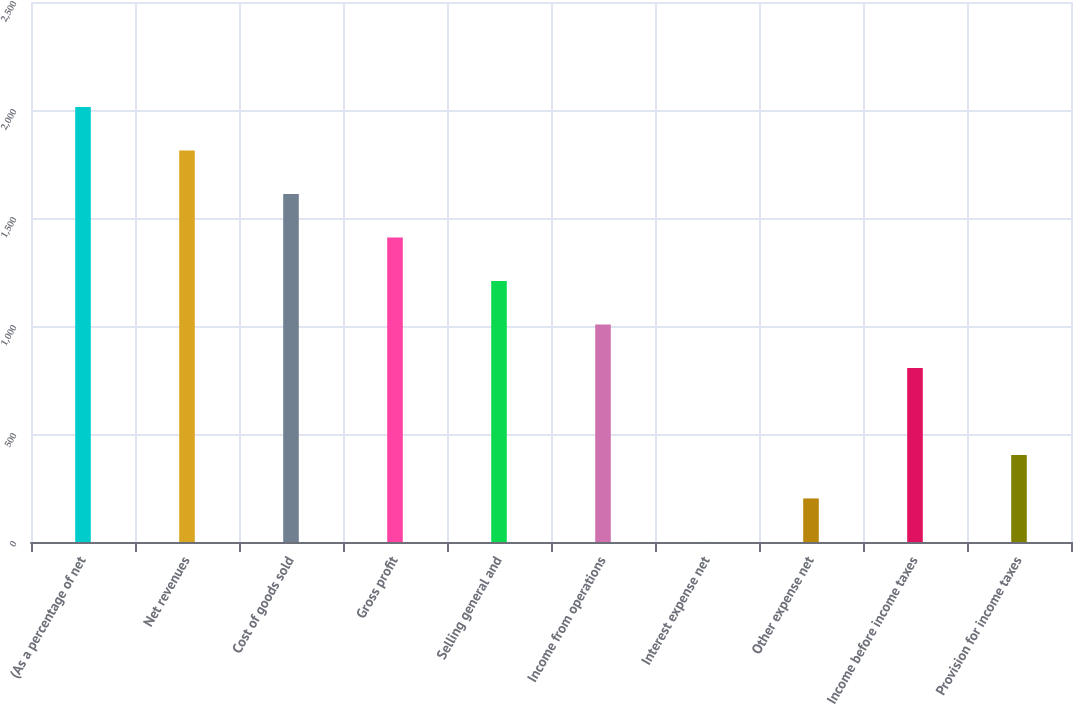Convert chart to OTSL. <chart><loc_0><loc_0><loc_500><loc_500><bar_chart><fcel>(As a percentage of net<fcel>Net revenues<fcel>Cost of goods sold<fcel>Gross profit<fcel>Selling general and<fcel>Income from operations<fcel>Interest expense net<fcel>Other expense net<fcel>Income before income taxes<fcel>Provision for income taxes<nl><fcel>2014<fcel>1812.62<fcel>1611.24<fcel>1409.86<fcel>1208.48<fcel>1007.1<fcel>0.2<fcel>201.58<fcel>805.72<fcel>402.96<nl></chart> 